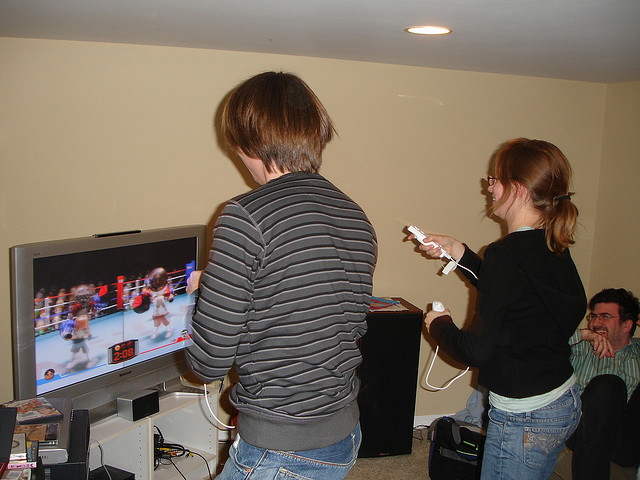Please identify all text content in this image. 2.08 